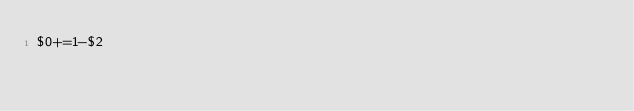<code> <loc_0><loc_0><loc_500><loc_500><_Awk_>$0+=1-$2</code> 